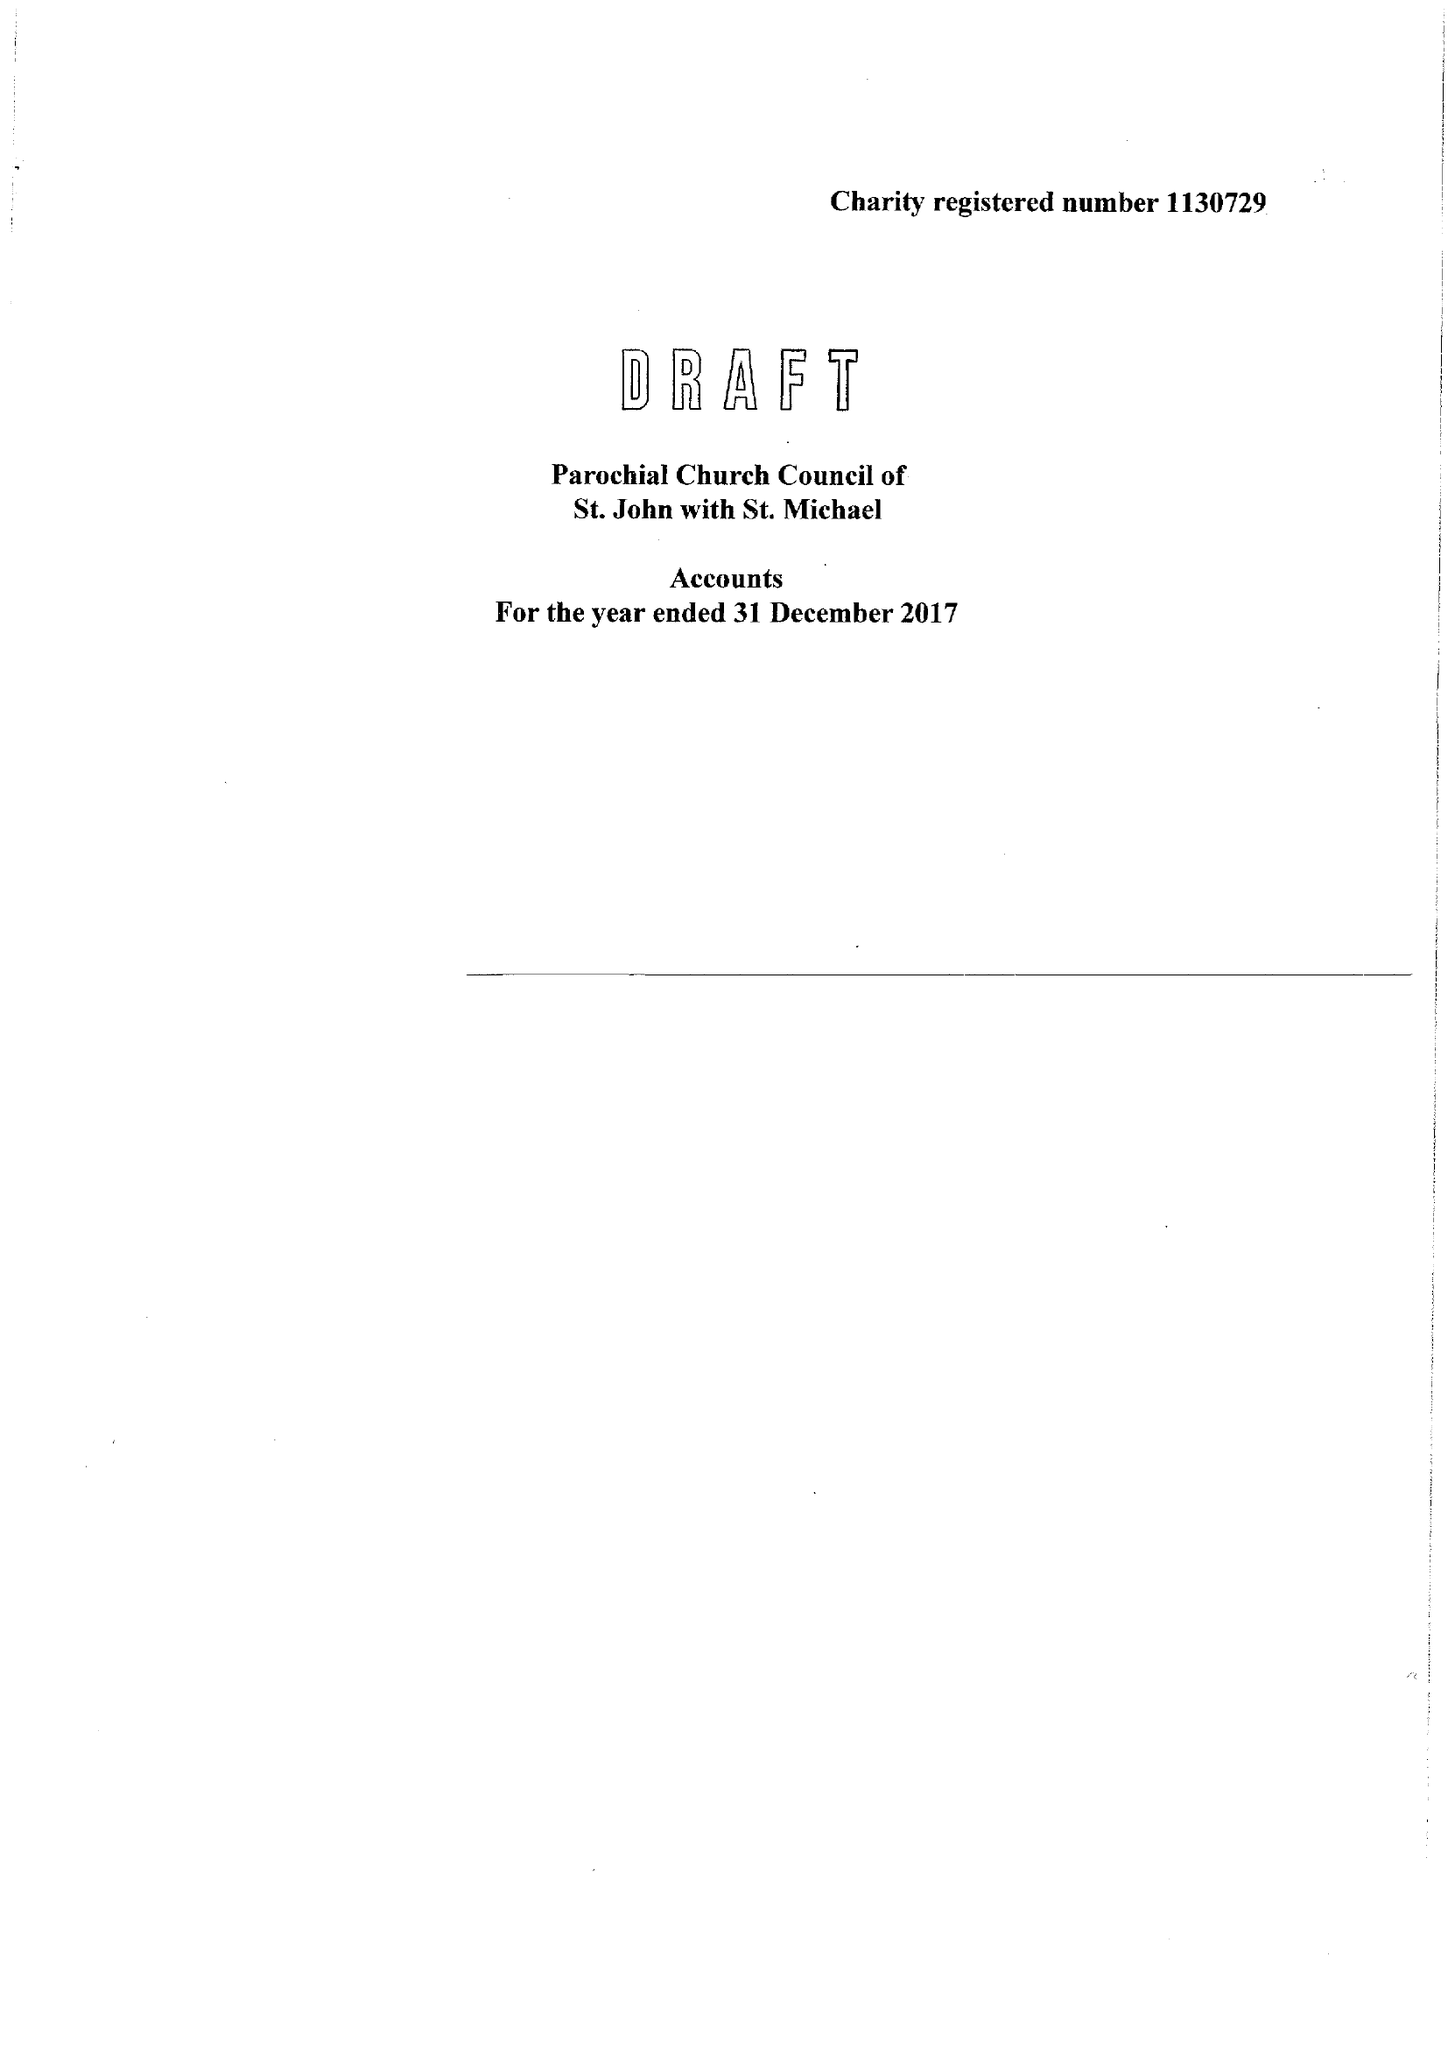What is the value for the address__postcode?
Answer the question using a single word or phrase. None 